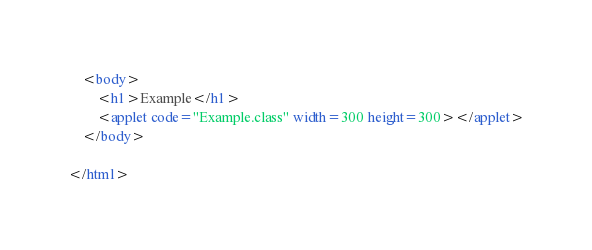<code> <loc_0><loc_0><loc_500><loc_500><_HTML_>	<body>
		<h1>Example</h1>
		<applet code="Example.class" width=300 height=300></applet>
	</body>

</html>
</code> 